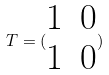Convert formula to latex. <formula><loc_0><loc_0><loc_500><loc_500>T = ( \begin{matrix} 1 & 0 \\ 1 & 0 \end{matrix} )</formula> 